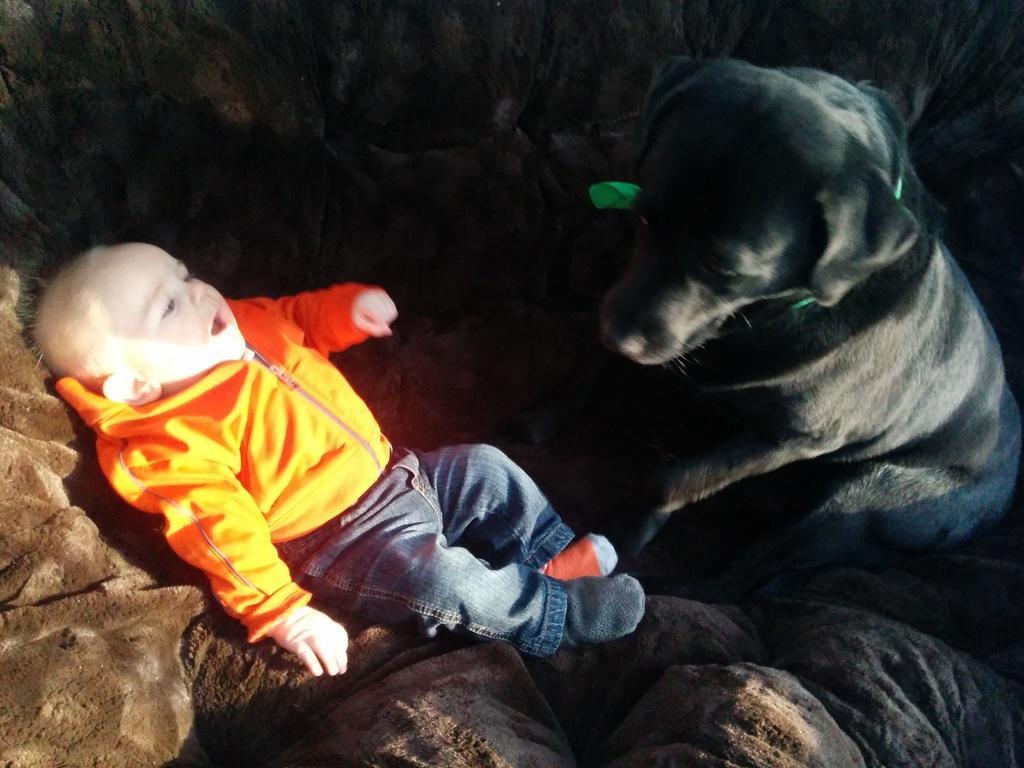How would you summarize this image in a sentence or two? In this picture we can see a boy wore jacket sleeping on floor beside to him there is a black color dog and this boy wore socks to his foot and in background it is dark. 